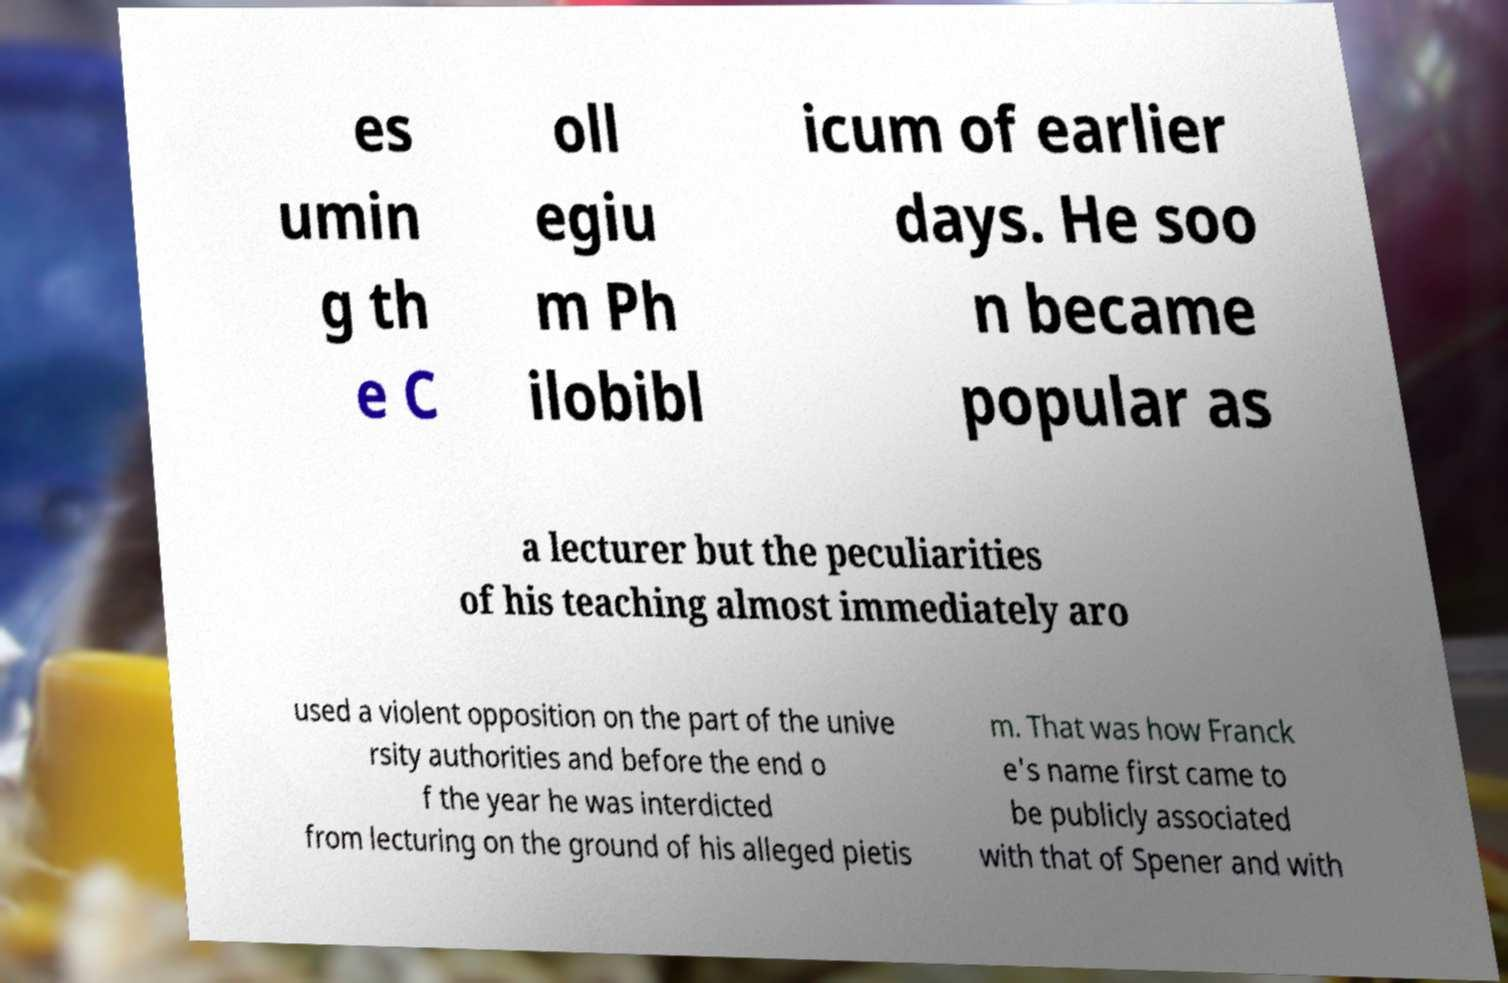What messages or text are displayed in this image? I need them in a readable, typed format. es umin g th e C oll egiu m Ph ilobibl icum of earlier days. He soo n became popular as a lecturer but the peculiarities of his teaching almost immediately aro used a violent opposition on the part of the unive rsity authorities and before the end o f the year he was interdicted from lecturing on the ground of his alleged pietis m. That was how Franck e's name first came to be publicly associated with that of Spener and with 